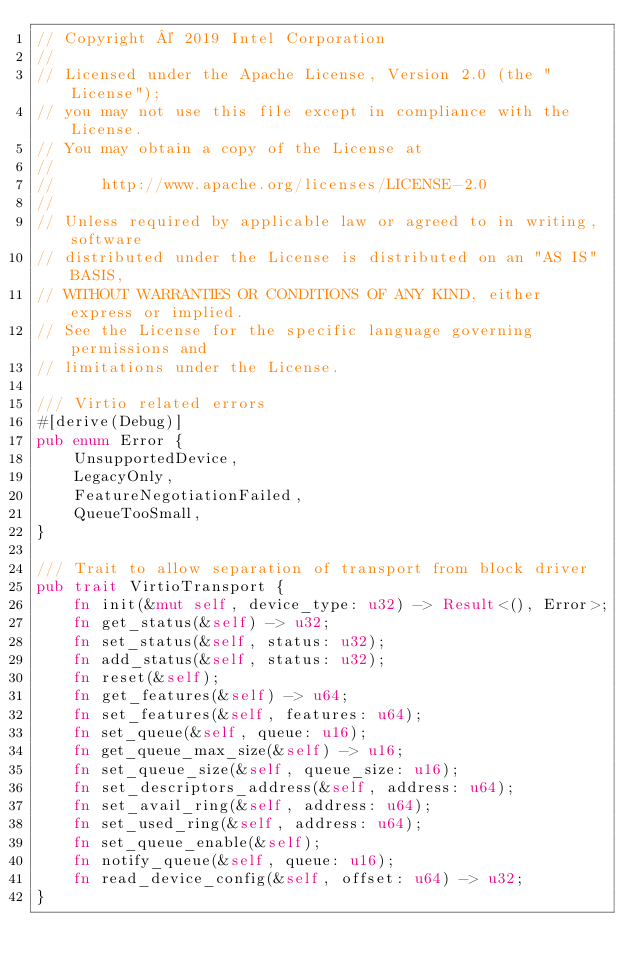<code> <loc_0><loc_0><loc_500><loc_500><_Rust_>// Copyright © 2019 Intel Corporation
//
// Licensed under the Apache License, Version 2.0 (the "License");
// you may not use this file except in compliance with the License.
// You may obtain a copy of the License at
//
//     http://www.apache.org/licenses/LICENSE-2.0
//
// Unless required by applicable law or agreed to in writing, software
// distributed under the License is distributed on an "AS IS" BASIS,
// WITHOUT WARRANTIES OR CONDITIONS OF ANY KIND, either express or implied.
// See the License for the specific language governing permissions and
// limitations under the License.

/// Virtio related errors
#[derive(Debug)]
pub enum Error {
    UnsupportedDevice,
    LegacyOnly,
    FeatureNegotiationFailed,
    QueueTooSmall,
}

/// Trait to allow separation of transport from block driver
pub trait VirtioTransport {
    fn init(&mut self, device_type: u32) -> Result<(), Error>;
    fn get_status(&self) -> u32;
    fn set_status(&self, status: u32);
    fn add_status(&self, status: u32);
    fn reset(&self);
    fn get_features(&self) -> u64;
    fn set_features(&self, features: u64);
    fn set_queue(&self, queue: u16);
    fn get_queue_max_size(&self) -> u16;
    fn set_queue_size(&self, queue_size: u16);
    fn set_descriptors_address(&self, address: u64);
    fn set_avail_ring(&self, address: u64);
    fn set_used_ring(&self, address: u64);
    fn set_queue_enable(&self);
    fn notify_queue(&self, queue: u16);
    fn read_device_config(&self, offset: u64) -> u32;
}
</code> 